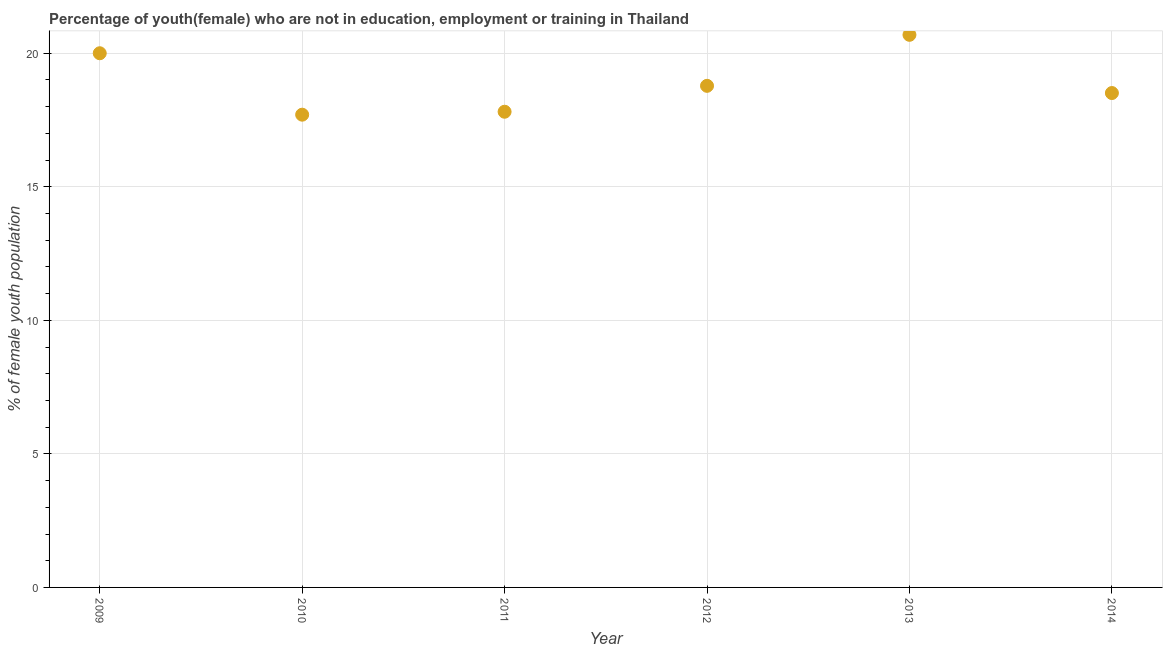What is the unemployed female youth population in 2012?
Provide a succinct answer. 18.78. Across all years, what is the maximum unemployed female youth population?
Offer a terse response. 20.69. Across all years, what is the minimum unemployed female youth population?
Make the answer very short. 17.7. In which year was the unemployed female youth population maximum?
Offer a very short reply. 2013. In which year was the unemployed female youth population minimum?
Give a very brief answer. 2010. What is the sum of the unemployed female youth population?
Your answer should be compact. 113.49. What is the difference between the unemployed female youth population in 2011 and 2013?
Ensure brevity in your answer.  -2.88. What is the average unemployed female youth population per year?
Provide a succinct answer. 18.92. What is the median unemployed female youth population?
Provide a short and direct response. 18.65. In how many years, is the unemployed female youth population greater than 5 %?
Offer a very short reply. 6. What is the ratio of the unemployed female youth population in 2011 to that in 2012?
Ensure brevity in your answer.  0.95. Is the unemployed female youth population in 2009 less than that in 2012?
Give a very brief answer. No. What is the difference between the highest and the second highest unemployed female youth population?
Ensure brevity in your answer.  0.69. What is the difference between the highest and the lowest unemployed female youth population?
Your answer should be very brief. 2.99. Does the unemployed female youth population monotonically increase over the years?
Offer a very short reply. No. How many years are there in the graph?
Offer a terse response. 6. What is the title of the graph?
Your answer should be very brief. Percentage of youth(female) who are not in education, employment or training in Thailand. What is the label or title of the X-axis?
Your answer should be compact. Year. What is the label or title of the Y-axis?
Your answer should be very brief. % of female youth population. What is the % of female youth population in 2009?
Offer a very short reply. 20. What is the % of female youth population in 2010?
Make the answer very short. 17.7. What is the % of female youth population in 2011?
Offer a very short reply. 17.81. What is the % of female youth population in 2012?
Your answer should be compact. 18.78. What is the % of female youth population in 2013?
Your answer should be compact. 20.69. What is the % of female youth population in 2014?
Provide a short and direct response. 18.51. What is the difference between the % of female youth population in 2009 and 2011?
Your answer should be compact. 2.19. What is the difference between the % of female youth population in 2009 and 2012?
Make the answer very short. 1.22. What is the difference between the % of female youth population in 2009 and 2013?
Provide a succinct answer. -0.69. What is the difference between the % of female youth population in 2009 and 2014?
Provide a succinct answer. 1.49. What is the difference between the % of female youth population in 2010 and 2011?
Make the answer very short. -0.11. What is the difference between the % of female youth population in 2010 and 2012?
Offer a very short reply. -1.08. What is the difference between the % of female youth population in 2010 and 2013?
Ensure brevity in your answer.  -2.99. What is the difference between the % of female youth population in 2010 and 2014?
Your response must be concise. -0.81. What is the difference between the % of female youth population in 2011 and 2012?
Offer a very short reply. -0.97. What is the difference between the % of female youth population in 2011 and 2013?
Keep it short and to the point. -2.88. What is the difference between the % of female youth population in 2012 and 2013?
Provide a short and direct response. -1.91. What is the difference between the % of female youth population in 2012 and 2014?
Give a very brief answer. 0.27. What is the difference between the % of female youth population in 2013 and 2014?
Your answer should be compact. 2.18. What is the ratio of the % of female youth population in 2009 to that in 2010?
Your response must be concise. 1.13. What is the ratio of the % of female youth population in 2009 to that in 2011?
Offer a very short reply. 1.12. What is the ratio of the % of female youth population in 2009 to that in 2012?
Offer a very short reply. 1.06. What is the ratio of the % of female youth population in 2009 to that in 2013?
Ensure brevity in your answer.  0.97. What is the ratio of the % of female youth population in 2009 to that in 2014?
Provide a short and direct response. 1.08. What is the ratio of the % of female youth population in 2010 to that in 2012?
Offer a very short reply. 0.94. What is the ratio of the % of female youth population in 2010 to that in 2013?
Offer a terse response. 0.85. What is the ratio of the % of female youth population in 2010 to that in 2014?
Offer a terse response. 0.96. What is the ratio of the % of female youth population in 2011 to that in 2012?
Your response must be concise. 0.95. What is the ratio of the % of female youth population in 2011 to that in 2013?
Your answer should be compact. 0.86. What is the ratio of the % of female youth population in 2011 to that in 2014?
Your answer should be very brief. 0.96. What is the ratio of the % of female youth population in 2012 to that in 2013?
Offer a very short reply. 0.91. What is the ratio of the % of female youth population in 2013 to that in 2014?
Provide a short and direct response. 1.12. 